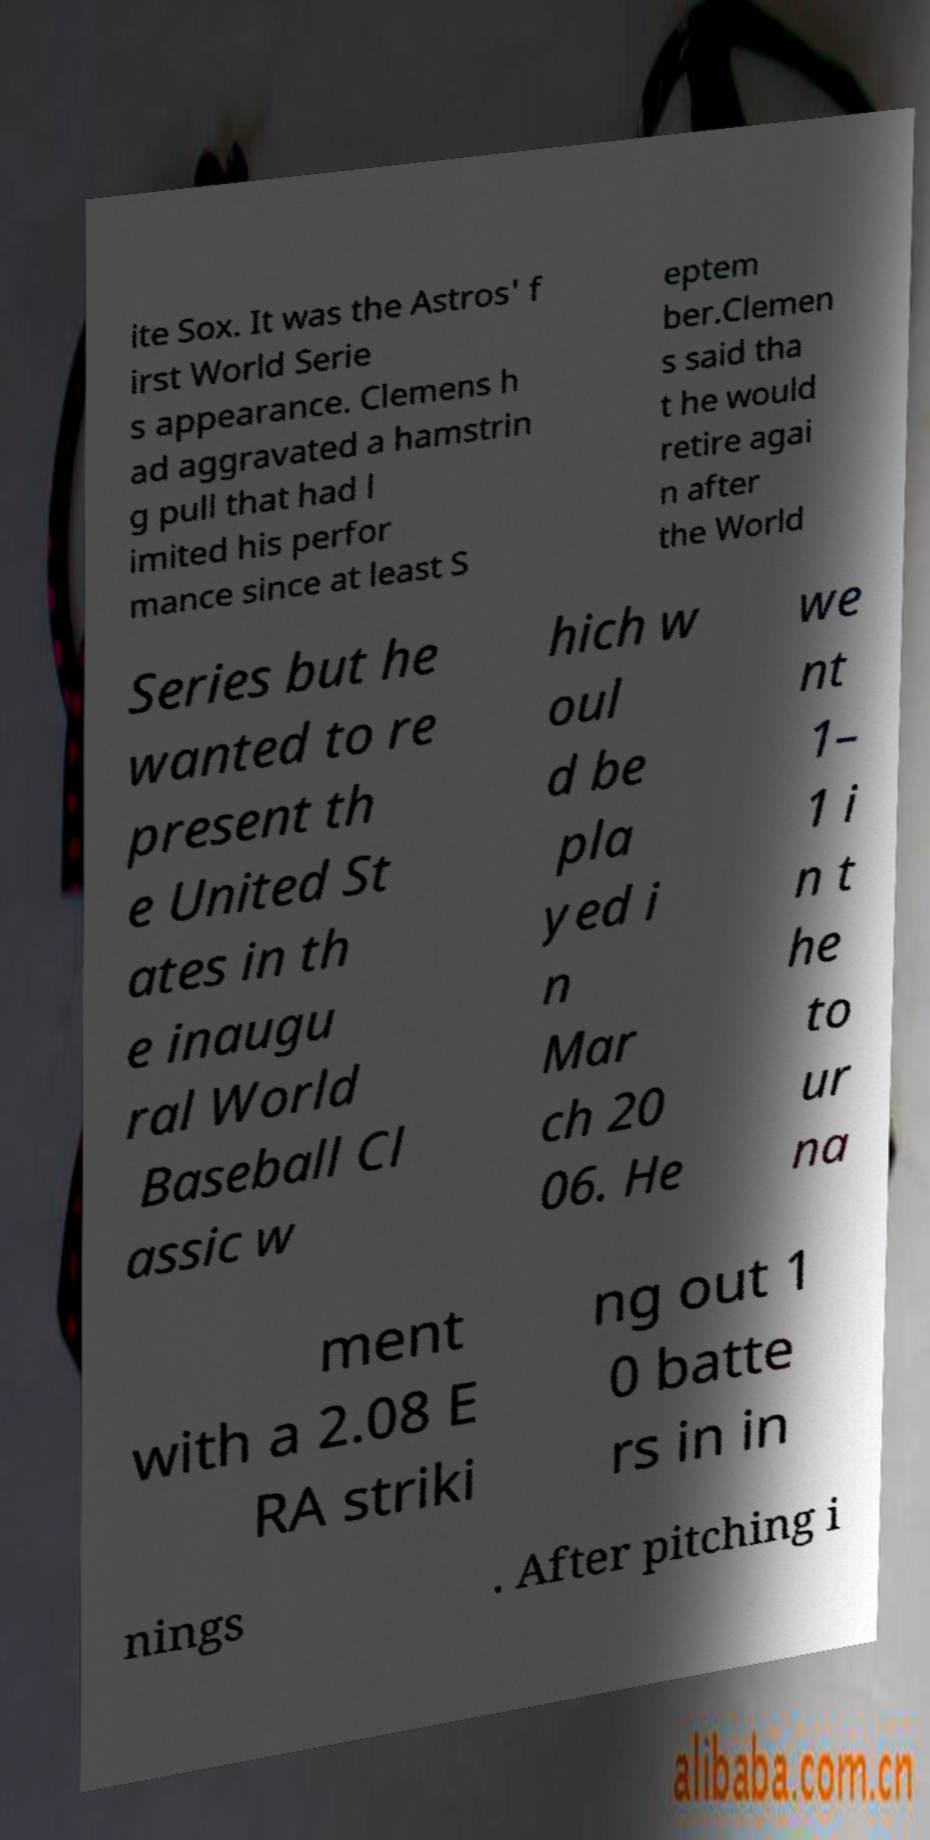For documentation purposes, I need the text within this image transcribed. Could you provide that? ite Sox. It was the Astros' f irst World Serie s appearance. Clemens h ad aggravated a hamstrin g pull that had l imited his perfor mance since at least S eptem ber.Clemen s said tha t he would retire agai n after the World Series but he wanted to re present th e United St ates in th e inaugu ral World Baseball Cl assic w hich w oul d be pla yed i n Mar ch 20 06. He we nt 1– 1 i n t he to ur na ment with a 2.08 E RA striki ng out 1 0 batte rs in in nings . After pitching i 